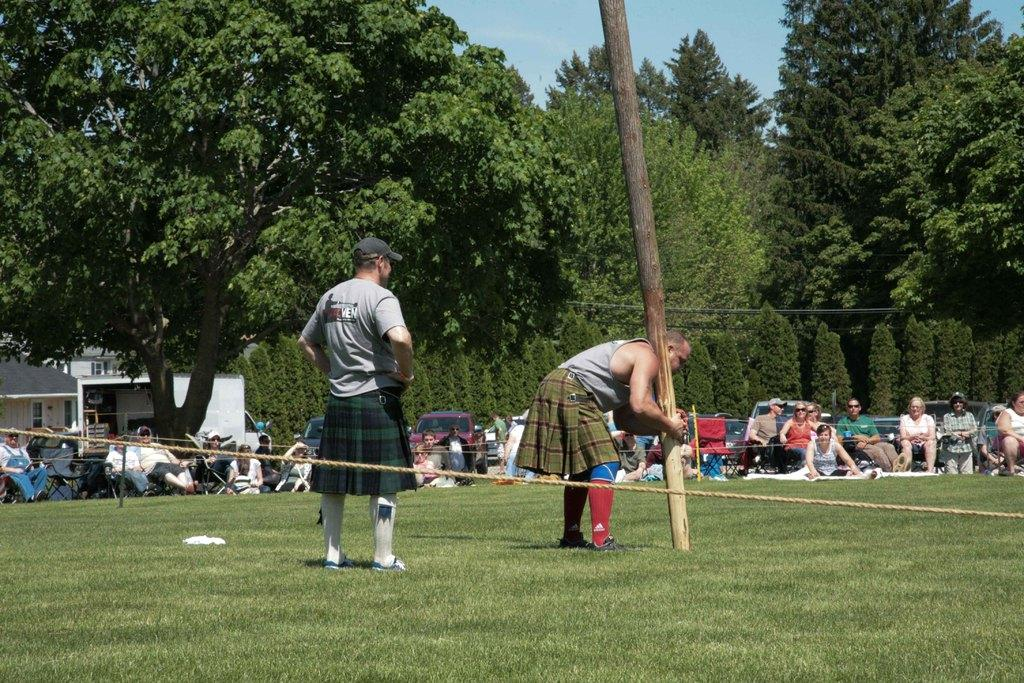What is the main subject of the image? There is a person standing in the image. What is the person wearing? The person is wearing a cap. What is the person holding in the image? The person is holding a wooden pole. What type of vegetation can be seen in the image? There is grass visible in the image. What other objects can be seen in the image? There is a rope in the image. What can be seen in the background of the image? The background of the image includes trees, houses, people, and the sky. What type of corn is being harvested by the beggar in the image? There is no beggar or corn present in the image. What is the person using the needle for in the image? There is no needle present in the image. 